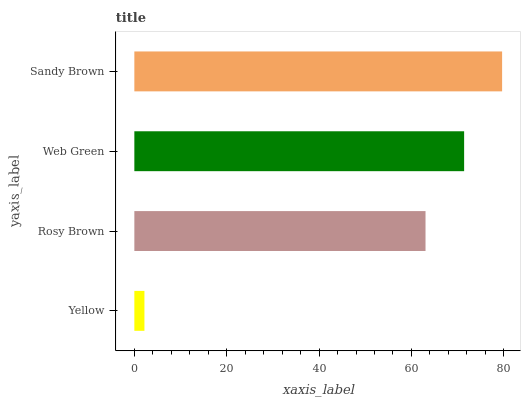Is Yellow the minimum?
Answer yes or no. Yes. Is Sandy Brown the maximum?
Answer yes or no. Yes. Is Rosy Brown the minimum?
Answer yes or no. No. Is Rosy Brown the maximum?
Answer yes or no. No. Is Rosy Brown greater than Yellow?
Answer yes or no. Yes. Is Yellow less than Rosy Brown?
Answer yes or no. Yes. Is Yellow greater than Rosy Brown?
Answer yes or no. No. Is Rosy Brown less than Yellow?
Answer yes or no. No. Is Web Green the high median?
Answer yes or no. Yes. Is Rosy Brown the low median?
Answer yes or no. Yes. Is Sandy Brown the high median?
Answer yes or no. No. Is Web Green the low median?
Answer yes or no. No. 